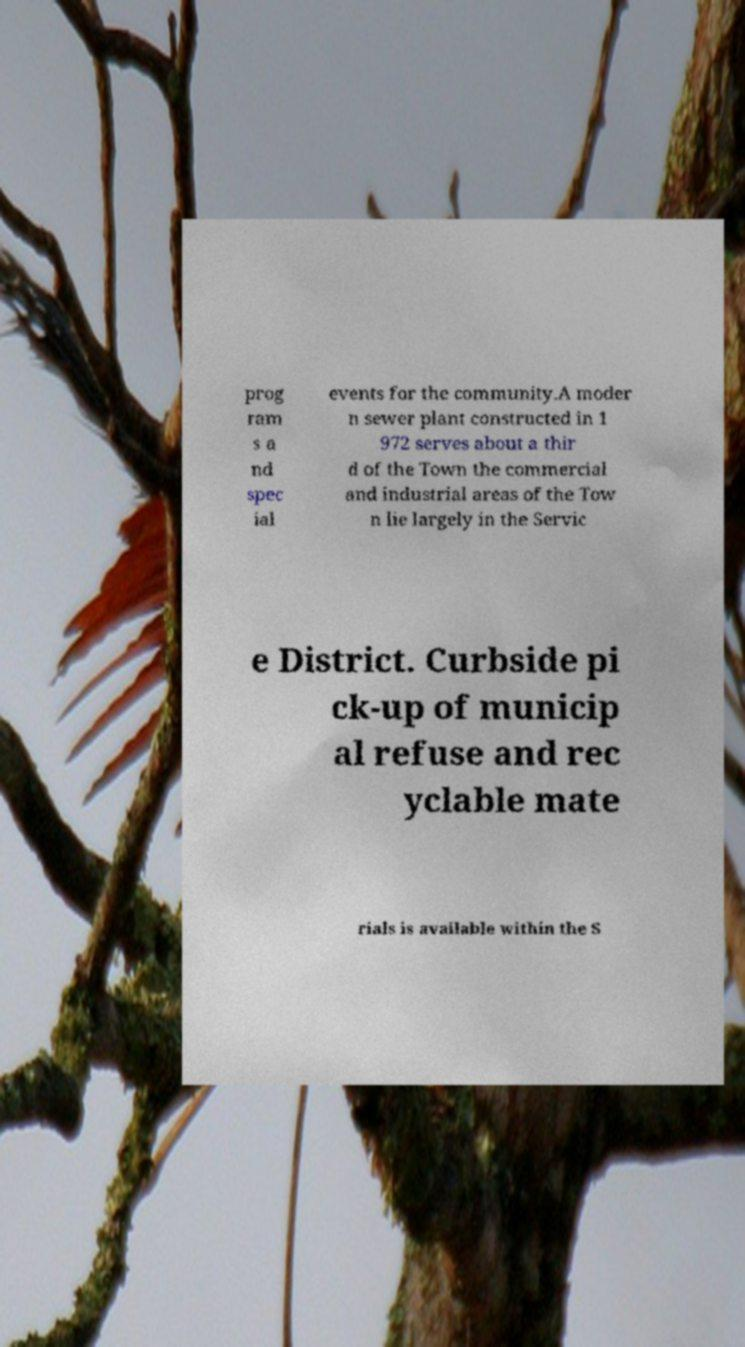There's text embedded in this image that I need extracted. Can you transcribe it verbatim? prog ram s a nd spec ial events for the community.A moder n sewer plant constructed in 1 972 serves about a thir d of the Town the commercial and industrial areas of the Tow n lie largely in the Servic e District. Curbside pi ck-up of municip al refuse and rec yclable mate rials is available within the S 